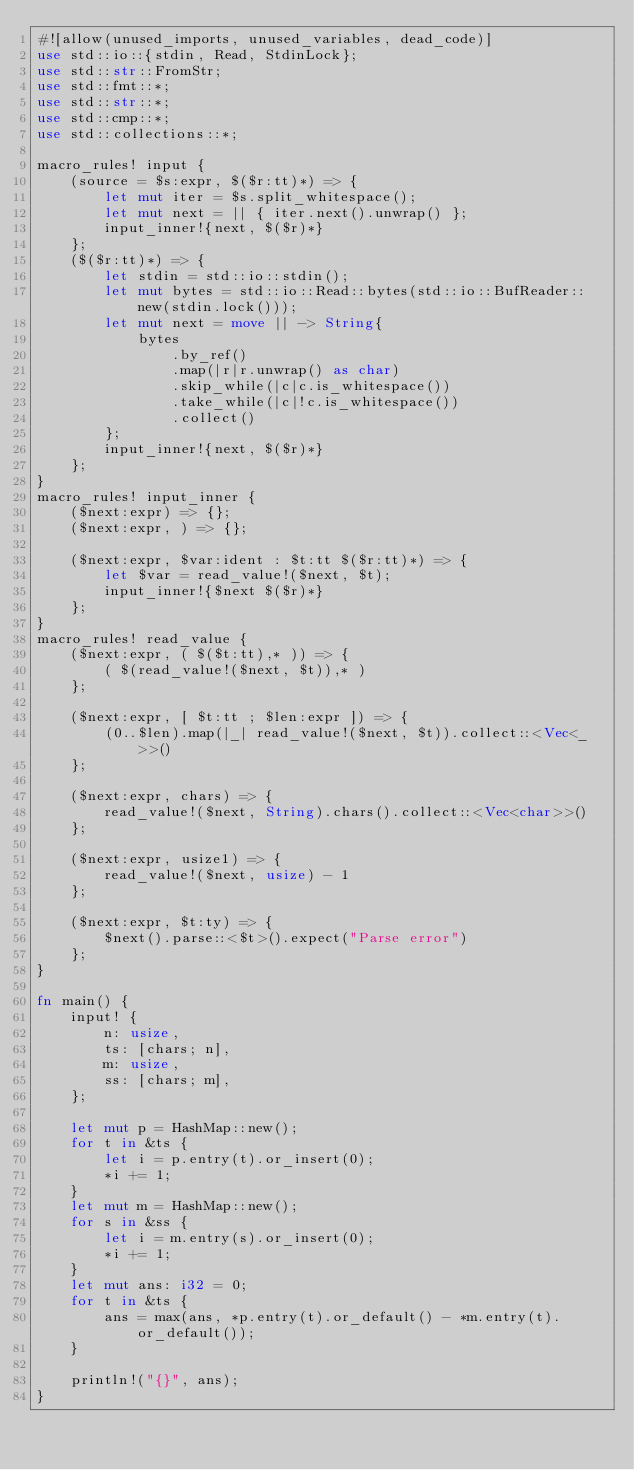<code> <loc_0><loc_0><loc_500><loc_500><_Rust_>#![allow(unused_imports, unused_variables, dead_code)]
use std::io::{stdin, Read, StdinLock};
use std::str::FromStr;
use std::fmt::*;
use std::str::*;
use std::cmp::*;
use std::collections::*;

macro_rules! input {
    (source = $s:expr, $($r:tt)*) => {
        let mut iter = $s.split_whitespace();
        let mut next = || { iter.next().unwrap() };
        input_inner!{next, $($r)*}
    };
    ($($r:tt)*) => {
        let stdin = std::io::stdin();
        let mut bytes = std::io::Read::bytes(std::io::BufReader::new(stdin.lock()));
        let mut next = move || -> String{
            bytes
                .by_ref()
                .map(|r|r.unwrap() as char)
                .skip_while(|c|c.is_whitespace())
                .take_while(|c|!c.is_whitespace())
                .collect()
        };
        input_inner!{next, $($r)*}
    };
}
macro_rules! input_inner {
    ($next:expr) => {};
    ($next:expr, ) => {};

    ($next:expr, $var:ident : $t:tt $($r:tt)*) => {
        let $var = read_value!($next, $t);
        input_inner!{$next $($r)*}
    };
}
macro_rules! read_value {
    ($next:expr, ( $($t:tt),* )) => {
        ( $(read_value!($next, $t)),* )
    };

    ($next:expr, [ $t:tt ; $len:expr ]) => {
        (0..$len).map(|_| read_value!($next, $t)).collect::<Vec<_>>()
    };

    ($next:expr, chars) => {
        read_value!($next, String).chars().collect::<Vec<char>>()
    };

    ($next:expr, usize1) => {
        read_value!($next, usize) - 1
    };

    ($next:expr, $t:ty) => {
        $next().parse::<$t>().expect("Parse error")
    };
}

fn main() {
    input! {
        n: usize,
        ts: [chars; n],
        m: usize,
        ss: [chars; m],
    };

    let mut p = HashMap::new();
    for t in &ts {
        let i = p.entry(t).or_insert(0);
        *i += 1;
    }
    let mut m = HashMap::new();
    for s in &ss {
        let i = m.entry(s).or_insert(0);
        *i += 1;
    }
    let mut ans: i32 = 0;
    for t in &ts {
        ans = max(ans, *p.entry(t).or_default() - *m.entry(t).or_default());
    }

    println!("{}", ans);
}
</code> 